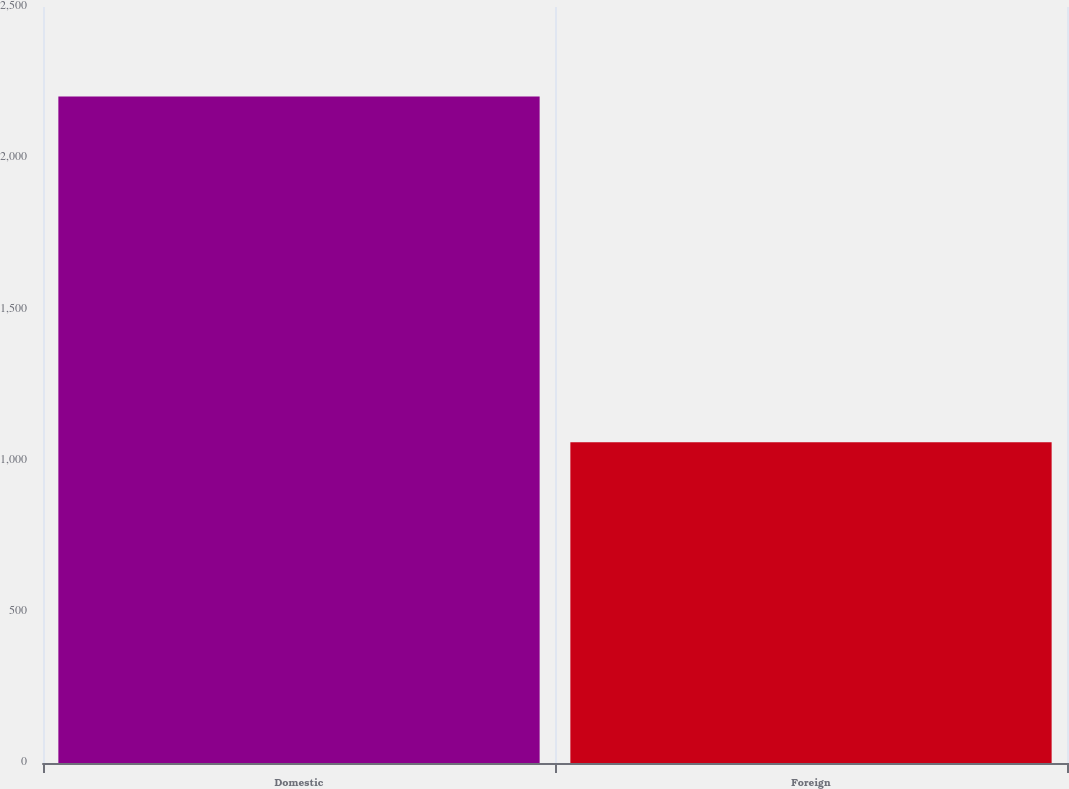Convert chart to OTSL. <chart><loc_0><loc_0><loc_500><loc_500><bar_chart><fcel>Domestic<fcel>Foreign<nl><fcel>2204<fcel>1061<nl></chart> 